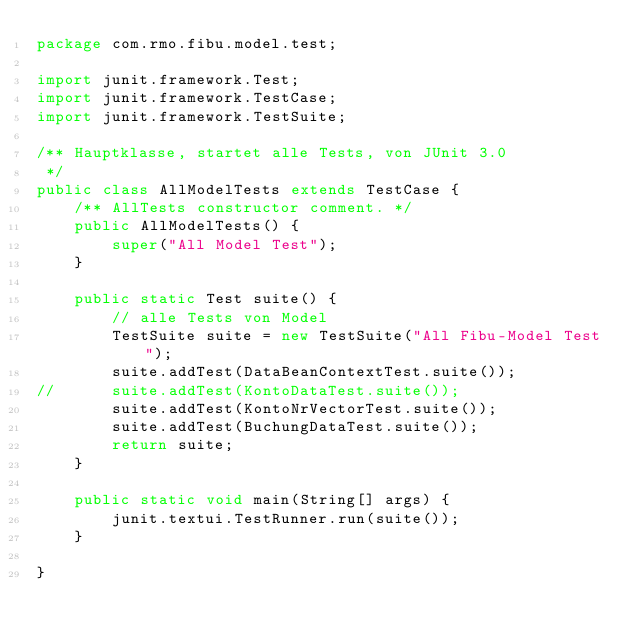<code> <loc_0><loc_0><loc_500><loc_500><_Java_>package com.rmo.fibu.model.test;

import junit.framework.Test;
import junit.framework.TestCase;
import junit.framework.TestSuite;

/** Hauptklasse, startet alle Tests, von JUnit 3.0
 */
public class AllModelTests extends TestCase {
	/** AllTests constructor comment. */
	public AllModelTests() {
		super("All Model Test");
	}

	public static Test suite() {
		// alle Tests von Model
		TestSuite suite = new TestSuite("All Fibu-Model Test");
		suite.addTest(DataBeanContextTest.suite());
//		suite.addTest(KontoDataTest.suite());
		suite.addTest(KontoNrVectorTest.suite());
		suite.addTest(BuchungDataTest.suite());
		return suite;
	}

	public static void main(String[] args) {
		junit.textui.TestRunner.run(suite());
	}

}
</code> 